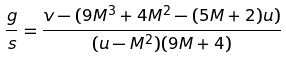Convert formula to latex. <formula><loc_0><loc_0><loc_500><loc_500>\frac { g } { s } = \frac { v - ( 9 M ^ { 3 } + 4 M ^ { 2 } - ( 5 M + 2 ) u ) } { ( u - M ^ { 2 } ) ( 9 M + 4 ) }</formula> 